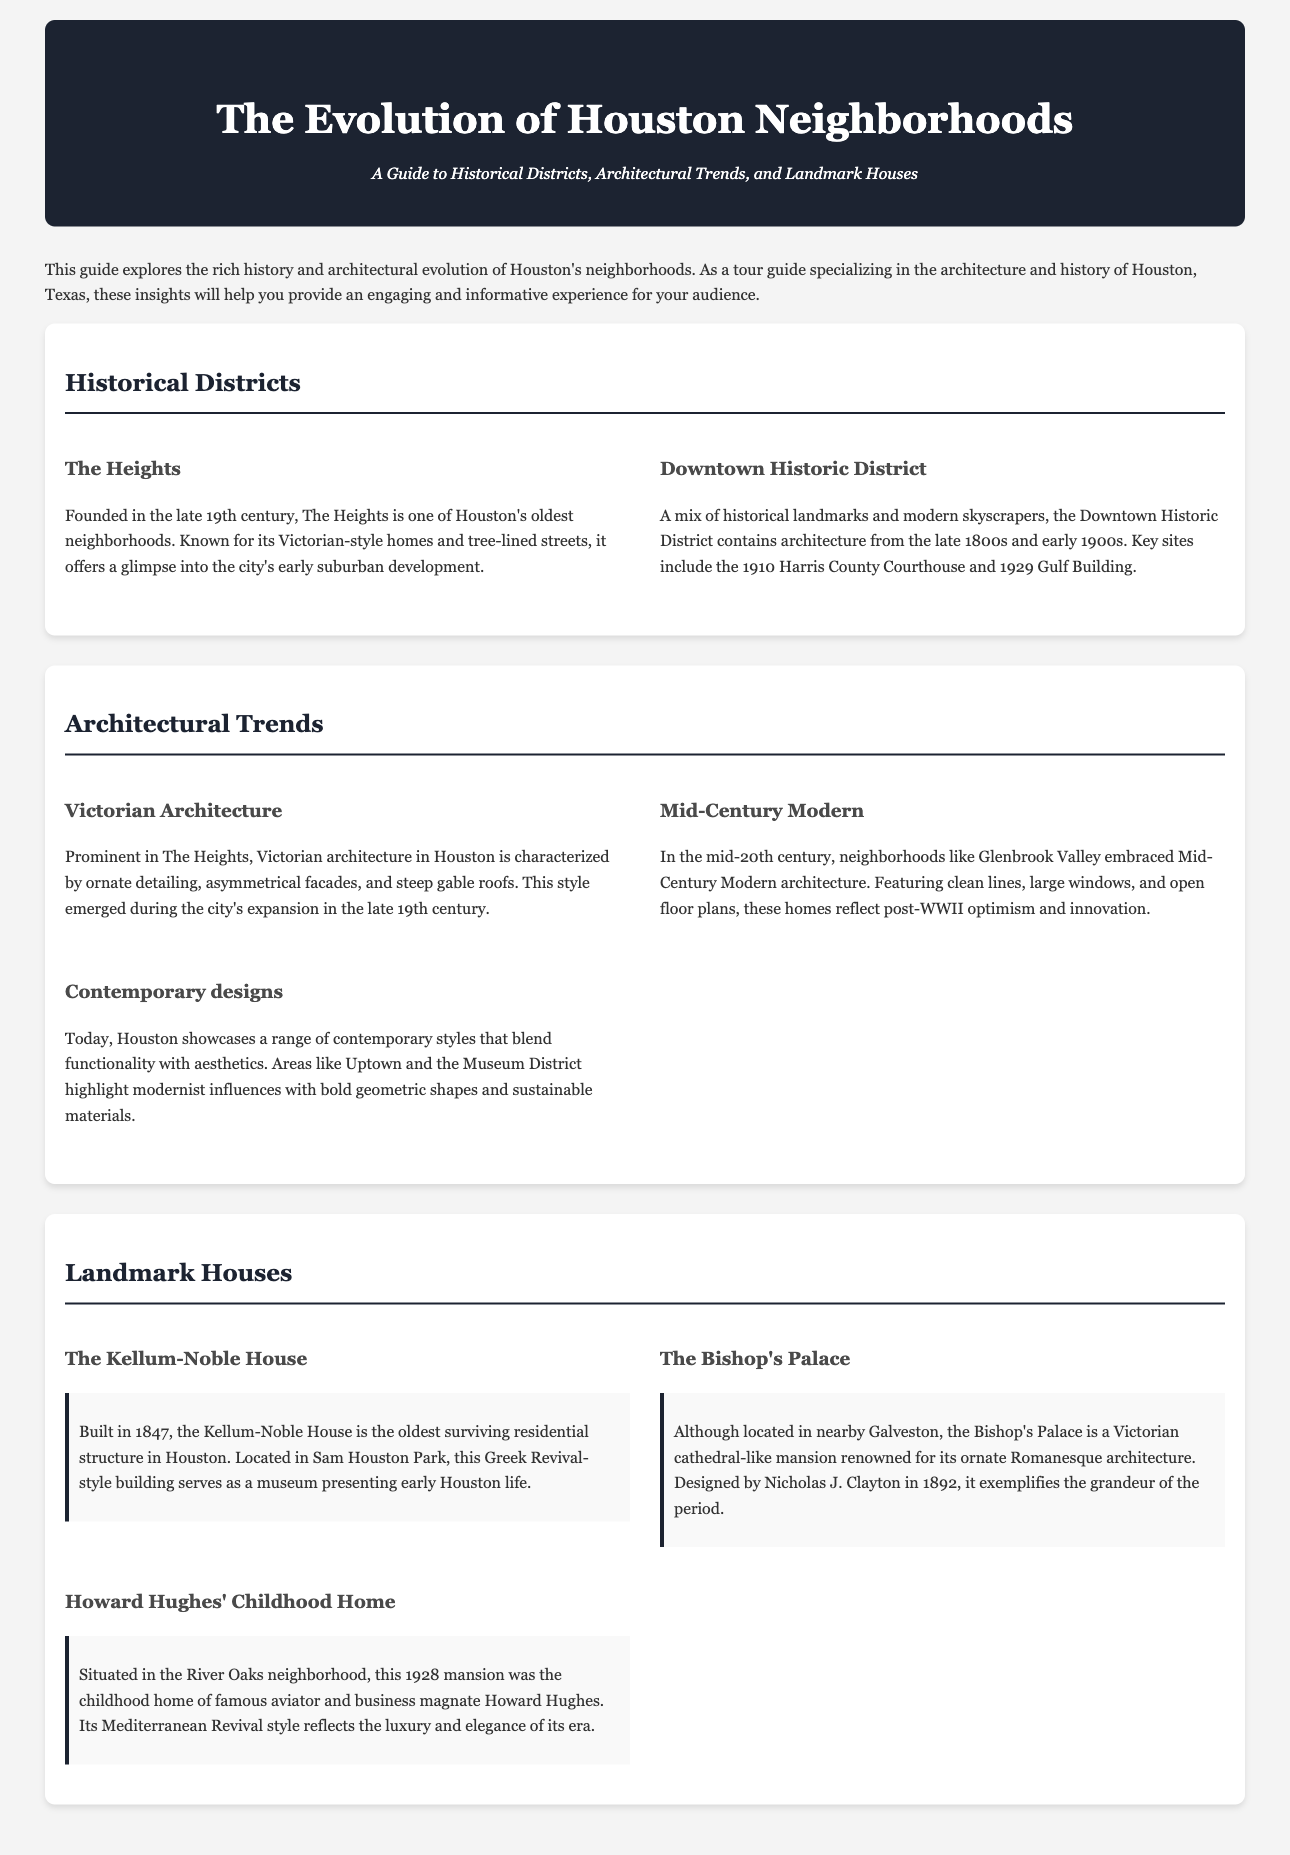What is the oldest neighborhood in Houston? The Heights is mentioned as one of Houston's oldest neighborhoods, founded in the late 19th century.
Answer: The Heights When was the Kellum-Noble House built? According to the document, the Kellum-Noble House was built in 1847.
Answer: 1847 Which architectural style is predominant in The Heights? The document states that Victorian architecture is prominent in The Heights.
Answer: Victorian architecture What year was the Bishop's Palace designed? The document notes that the Bishop's Palace was designed in 1892.
Answer: 1892 What is the primary architectural feature of Mid-Century Modern homes? The document highlights clean lines as a key feature of Mid-Century Modern architecture.
Answer: Clean lines In which neighborhood is Howard Hughes' childhood home located? The document explicitly states that Howard Hughes' childhood home is in the River Oaks neighborhood.
Answer: River Oaks What period does contemporary architecture in Houston reflect? The document indicates that contemporary architecture reflects modernist influences.
Answer: Modernist influences What is the specific style of the Kellum-Noble House? The document describes the Kellum-Noble House as a Greek Revival-style building.
Answer: Greek Revival What does the Downtown Historic District combine? The document states that the Downtown Historic District is a mix of historical landmarks and modern skyscrapers.
Answer: Historical landmarks and modern skyscrapers 